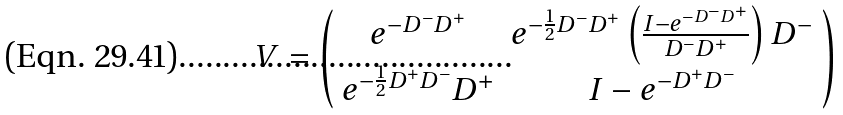<formula> <loc_0><loc_0><loc_500><loc_500>V = \left ( \begin{array} { c c } e ^ { - D ^ { - } D ^ { + } } & e ^ { - \frac { 1 } { 2 } D ^ { - } D ^ { + } } \left ( \frac { I - e ^ { - D ^ { - } D ^ { + } } } { D ^ { - } D ^ { + } } \right ) D ^ { - } \\ e ^ { - \frac { 1 } { 2 } D ^ { + } D ^ { - } } D ^ { + } & I - e ^ { - D ^ { + } D ^ { - } } \end{array} \right )</formula> 